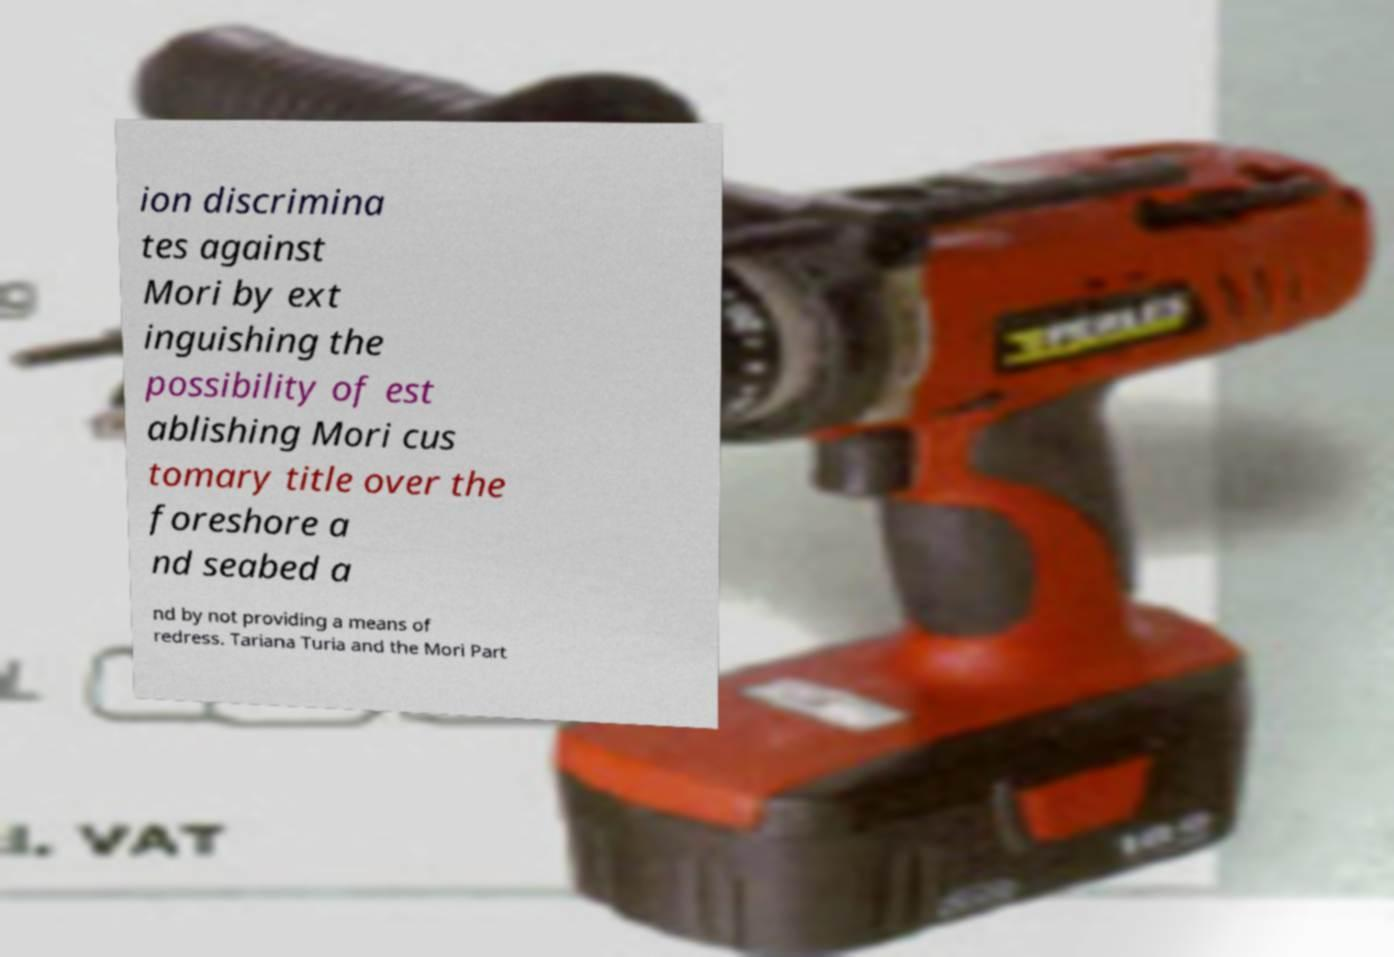For documentation purposes, I need the text within this image transcribed. Could you provide that? ion discrimina tes against Mori by ext inguishing the possibility of est ablishing Mori cus tomary title over the foreshore a nd seabed a nd by not providing a means of redress. Tariana Turia and the Mori Part 